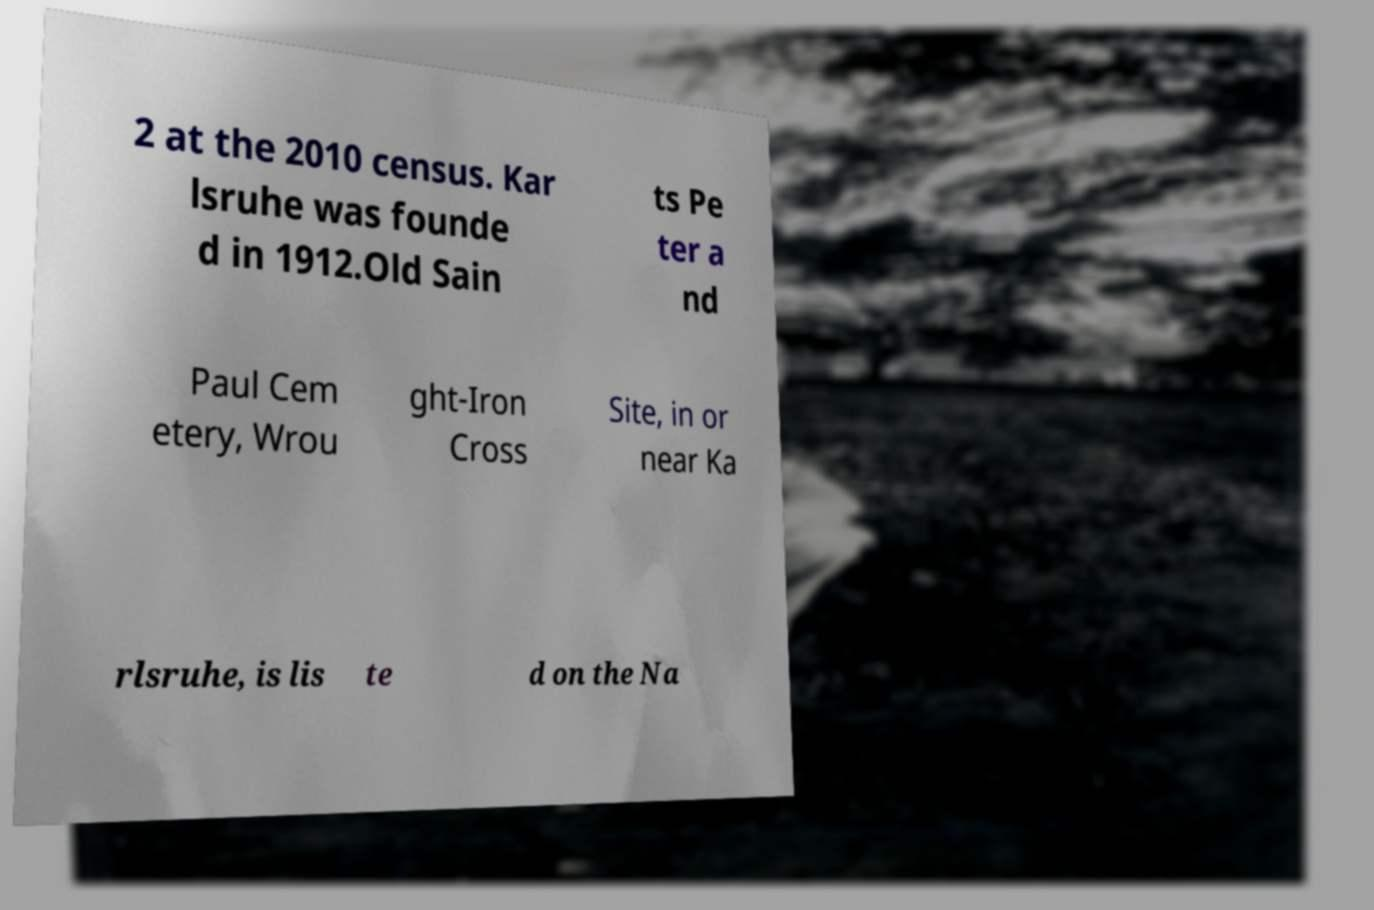Could you extract and type out the text from this image? 2 at the 2010 census. Kar lsruhe was founde d in 1912.Old Sain ts Pe ter a nd Paul Cem etery, Wrou ght-Iron Cross Site, in or near Ka rlsruhe, is lis te d on the Na 